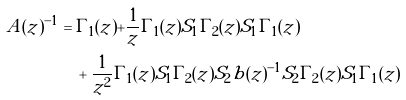<formula> <loc_0><loc_0><loc_500><loc_500>A ( z ) ^ { - 1 } & = \Gamma _ { 1 } ( z ) + \frac { 1 } { z } \Gamma _ { 1 } ( z ) S _ { 1 } \Gamma _ { 2 } ( z ) S _ { 1 } \Gamma _ { 1 } ( z ) \\ & \quad + \frac { 1 } { z ^ { 2 } } \Gamma _ { 1 } ( z ) S _ { 1 } \Gamma _ { 2 } ( z ) S _ { 2 } b ( z ) ^ { - 1 } S _ { 2 } \Gamma _ { 2 } ( z ) S _ { 1 } \Gamma _ { 1 } ( z )</formula> 